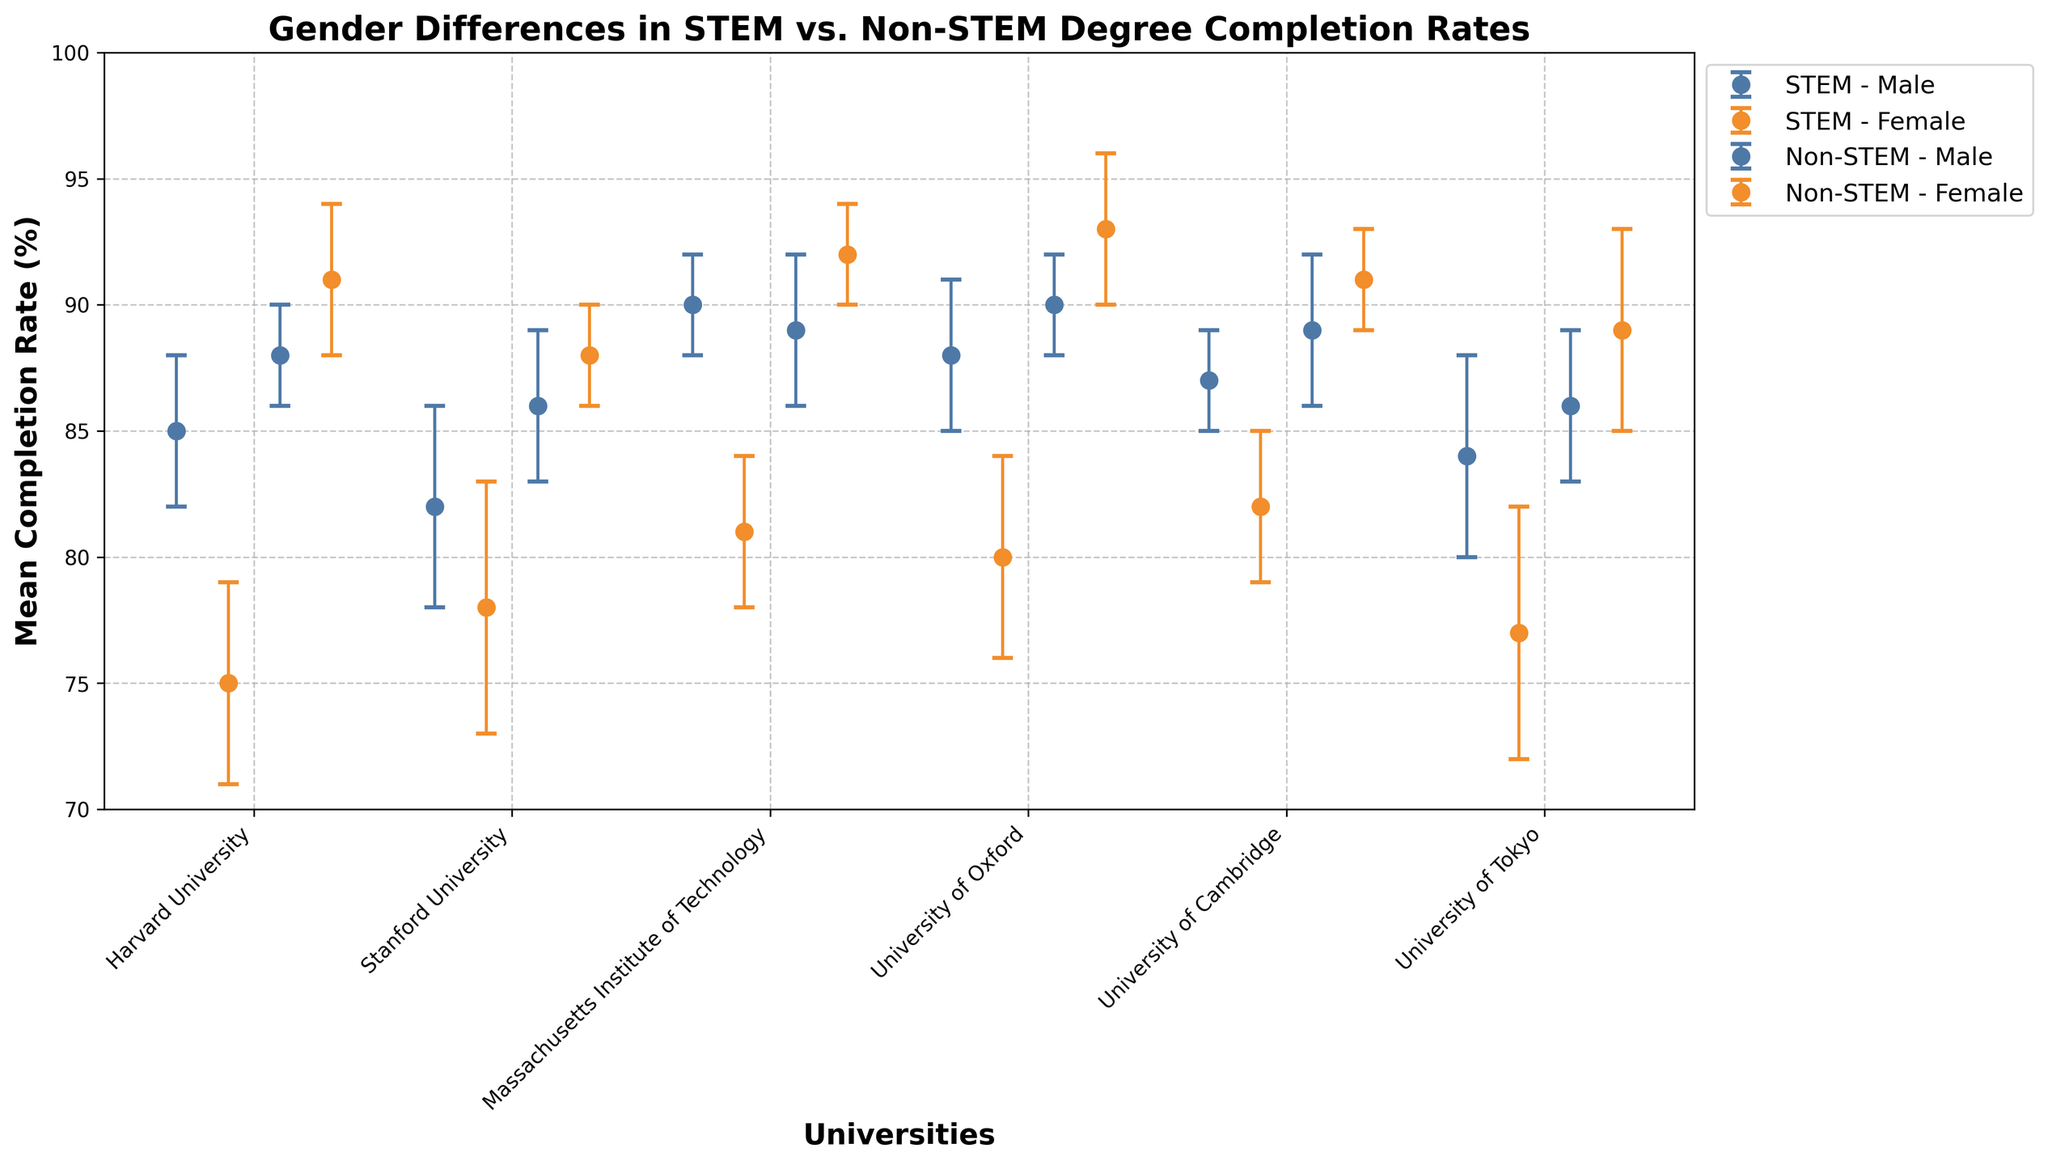what is the title of the plot? The title is usually located at the top of the plot. It summarizes what the plot represents. Here, it reads "Gender Differences in STEM vs. Non-STEM Degree Completion Rates".
Answer: Gender Differences in STEM vs. Non-STEM Degree Completion Rates Which university has the highest completion rate for non-STEM degrees among females? To find this, look at the highest data point marked for female non-STEM in the plot. The topmost dot for female non-STEM degrees is at the University of Oxford with a mean completion rate of 93%.
Answer: University of Oxford Which field has a smaller gender gap in degree completion at MIT? Compare the completion rates of males and females for both STEM and non-STEM fields at MIT. The gap for STEM (90% male, 81% female) is 9%, while for non-STEM it is smaller (89% male, 92% female) with a gap of 3%.
Answer: Non-STEM What is the completion rate difference in STEM degrees between males and females at the University of Tokyo? First, identify the data points for males and females in STEM at the University of Tokyo. Males have an 84% completion rate, while females have 77%. The difference is 84 - 77 = 7%.
Answer: 7% Which university has the smallest standard deviation for female non-STEM degrees? Identify the error bars for female non-STEM degrees and find the one with the shortest length. The University of Cambridge has the smallest standard deviation of 2 for female non-STEM degrees.
Answer: University of Cambridge Is there any university where females have a higher completion rate in non-STEM than males in STEM? Compare female non-STEM completion rates with male STEM rates across universities. For example, at Harvard, female non-STEM (91%) is higher than male STEM (85%).
Answer: Yes, Harvard University Which university shows the greatest difference in completion rates between STEM and non-STEM for males? Look at the completion rates for males in both fields across universities. The largest difference is at MIT: STEM (90%) vs. non-STEM (89%) gives a 1% difference.
Answer: Massachusetts Institute of Technology How do the completion rates for males in non-STEM compare across universities? Assess the mean completion rates for males in non-STEM fields at each university listed. They are generally quite high, ranging from 86% to 90%.
Answer: High, 86%-90% Does any university show an overlap in error bars between male and female STEM degrees? Overlap in error bars indicates overlap in ranges. At Stanford University, male STEM (82% ± 4) and female STEM (78% ± 5) error bars overlap significantly.
Answer: Yes, Stanford Which university has the highest variability in female STEM degree completion? Identify the female STEM completion rates and their standard deviations. The University of Tokyo has the highest standard deviation at 5%.
Answer: University of Tokyo 